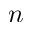Convert formula to latex. <formula><loc_0><loc_0><loc_500><loc_500>n</formula> 